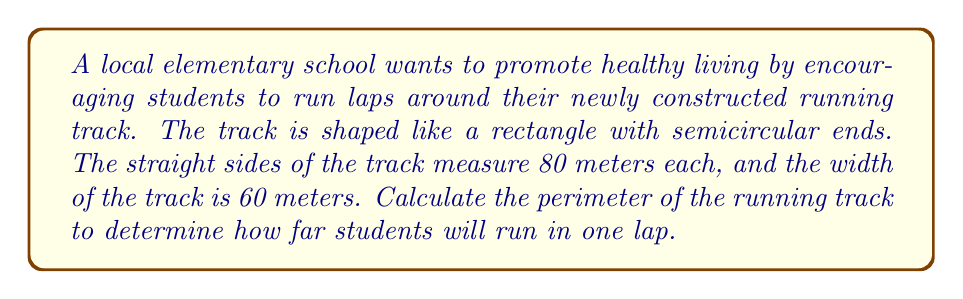Can you answer this question? Let's approach this step-by-step:

1) First, let's visualize the track:

[asy]
unitsize(1cm);
path p = (0,0)--(8,0)::(-3,0)..(3,0)::(-3,6)..(3,6)--(0,6);
draw(p);
label("80m", (4,0), S);
label("60m", (8,3), E);
[/asy]

2) The track consists of two straight sides and two semicircular ends.

3) For the straight sides:
   - There are two straight sides, each 80 meters long.
   - Total length of straight sides = $2 \times 80 = 160$ meters

4) For the semicircular ends:
   - The width of the track (60m) is the diameter of each semicircle.
   - The radius of each semicircle is half of this: $60 \div 2 = 30$ meters.
   - The circumference of a full circle would be $2\pi r$.
   - We only need half of this for each semicircle.
   - Length of one semicircle = $\pi r = \pi \times 30$ meters

5) There are two semicircular ends, so:
   - Total length of semicircular ends = $2 \times \pi \times 30$ meters

6) The perimeter of the track is the sum of all these parts:
   $$\text{Perimeter} = 160 + 2\pi \times 30$$

7) Simplifying:
   $$\text{Perimeter} = 160 + 60\pi \approx 348.50 \text{ meters}$$
Answer: $160 + 60\pi \approx 348.50$ meters 